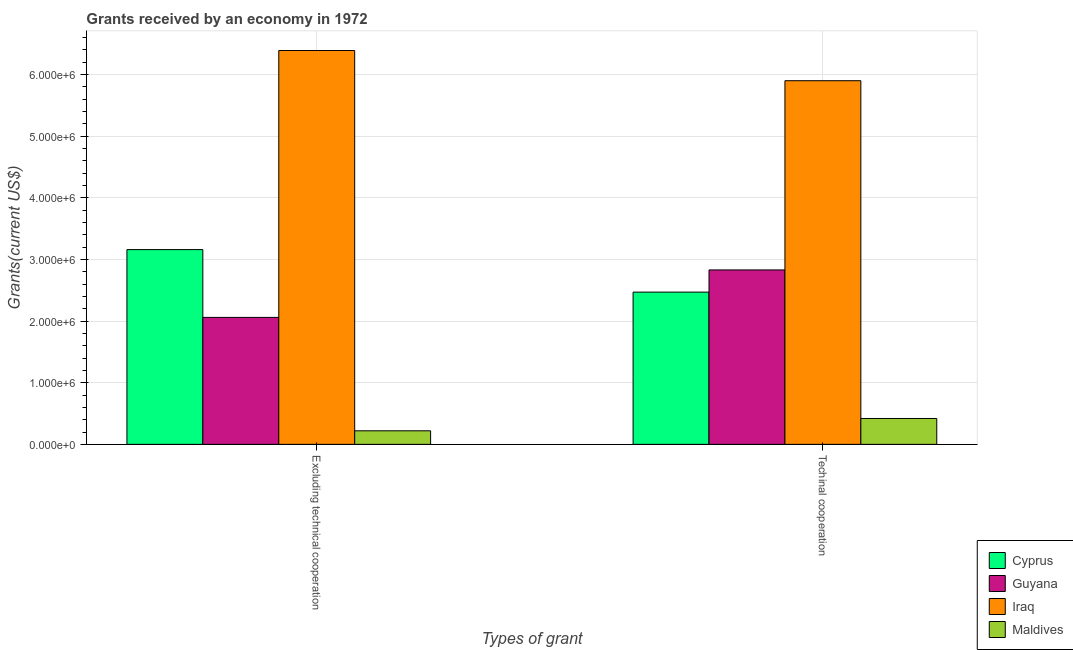How many groups of bars are there?
Your response must be concise. 2. Are the number of bars per tick equal to the number of legend labels?
Make the answer very short. Yes. Are the number of bars on each tick of the X-axis equal?
Offer a very short reply. Yes. How many bars are there on the 2nd tick from the left?
Provide a short and direct response. 4. What is the label of the 1st group of bars from the left?
Your answer should be very brief. Excluding technical cooperation. What is the amount of grants received(excluding technical cooperation) in Maldives?
Keep it short and to the point. 2.20e+05. Across all countries, what is the maximum amount of grants received(including technical cooperation)?
Your answer should be very brief. 5.90e+06. Across all countries, what is the minimum amount of grants received(including technical cooperation)?
Make the answer very short. 4.20e+05. In which country was the amount of grants received(excluding technical cooperation) maximum?
Your answer should be compact. Iraq. In which country was the amount of grants received(excluding technical cooperation) minimum?
Your response must be concise. Maldives. What is the total amount of grants received(excluding technical cooperation) in the graph?
Your answer should be compact. 1.18e+07. What is the difference between the amount of grants received(including technical cooperation) in Iraq and that in Cyprus?
Offer a terse response. 3.43e+06. What is the difference between the amount of grants received(including technical cooperation) in Cyprus and the amount of grants received(excluding technical cooperation) in Iraq?
Offer a terse response. -3.92e+06. What is the average amount of grants received(including technical cooperation) per country?
Your answer should be very brief. 2.90e+06. What is the difference between the amount of grants received(excluding technical cooperation) and amount of grants received(including technical cooperation) in Iraq?
Make the answer very short. 4.90e+05. What is the ratio of the amount of grants received(including technical cooperation) in Iraq to that in Cyprus?
Your answer should be compact. 2.39. What does the 3rd bar from the left in Techinal cooperation represents?
Keep it short and to the point. Iraq. What does the 1st bar from the right in Excluding technical cooperation represents?
Offer a terse response. Maldives. How many bars are there?
Your response must be concise. 8. Are the values on the major ticks of Y-axis written in scientific E-notation?
Offer a terse response. Yes. Does the graph contain grids?
Ensure brevity in your answer.  Yes. How are the legend labels stacked?
Offer a very short reply. Vertical. What is the title of the graph?
Make the answer very short. Grants received by an economy in 1972. What is the label or title of the X-axis?
Offer a very short reply. Types of grant. What is the label or title of the Y-axis?
Your response must be concise. Grants(current US$). What is the Grants(current US$) of Cyprus in Excluding technical cooperation?
Your answer should be very brief. 3.16e+06. What is the Grants(current US$) of Guyana in Excluding technical cooperation?
Offer a very short reply. 2.06e+06. What is the Grants(current US$) of Iraq in Excluding technical cooperation?
Provide a succinct answer. 6.39e+06. What is the Grants(current US$) in Cyprus in Techinal cooperation?
Keep it short and to the point. 2.47e+06. What is the Grants(current US$) of Guyana in Techinal cooperation?
Provide a short and direct response. 2.83e+06. What is the Grants(current US$) in Iraq in Techinal cooperation?
Provide a short and direct response. 5.90e+06. What is the Grants(current US$) of Maldives in Techinal cooperation?
Give a very brief answer. 4.20e+05. Across all Types of grant, what is the maximum Grants(current US$) of Cyprus?
Provide a short and direct response. 3.16e+06. Across all Types of grant, what is the maximum Grants(current US$) of Guyana?
Your response must be concise. 2.83e+06. Across all Types of grant, what is the maximum Grants(current US$) in Iraq?
Your response must be concise. 6.39e+06. Across all Types of grant, what is the minimum Grants(current US$) of Cyprus?
Offer a very short reply. 2.47e+06. Across all Types of grant, what is the minimum Grants(current US$) in Guyana?
Your answer should be very brief. 2.06e+06. Across all Types of grant, what is the minimum Grants(current US$) of Iraq?
Your answer should be very brief. 5.90e+06. Across all Types of grant, what is the minimum Grants(current US$) of Maldives?
Your answer should be compact. 2.20e+05. What is the total Grants(current US$) in Cyprus in the graph?
Your answer should be very brief. 5.63e+06. What is the total Grants(current US$) in Guyana in the graph?
Your answer should be compact. 4.89e+06. What is the total Grants(current US$) of Iraq in the graph?
Keep it short and to the point. 1.23e+07. What is the total Grants(current US$) of Maldives in the graph?
Make the answer very short. 6.40e+05. What is the difference between the Grants(current US$) of Cyprus in Excluding technical cooperation and that in Techinal cooperation?
Ensure brevity in your answer.  6.90e+05. What is the difference between the Grants(current US$) in Guyana in Excluding technical cooperation and that in Techinal cooperation?
Make the answer very short. -7.70e+05. What is the difference between the Grants(current US$) of Maldives in Excluding technical cooperation and that in Techinal cooperation?
Offer a terse response. -2.00e+05. What is the difference between the Grants(current US$) in Cyprus in Excluding technical cooperation and the Grants(current US$) in Iraq in Techinal cooperation?
Your response must be concise. -2.74e+06. What is the difference between the Grants(current US$) in Cyprus in Excluding technical cooperation and the Grants(current US$) in Maldives in Techinal cooperation?
Keep it short and to the point. 2.74e+06. What is the difference between the Grants(current US$) of Guyana in Excluding technical cooperation and the Grants(current US$) of Iraq in Techinal cooperation?
Offer a terse response. -3.84e+06. What is the difference between the Grants(current US$) in Guyana in Excluding technical cooperation and the Grants(current US$) in Maldives in Techinal cooperation?
Your answer should be compact. 1.64e+06. What is the difference between the Grants(current US$) in Iraq in Excluding technical cooperation and the Grants(current US$) in Maldives in Techinal cooperation?
Ensure brevity in your answer.  5.97e+06. What is the average Grants(current US$) in Cyprus per Types of grant?
Your response must be concise. 2.82e+06. What is the average Grants(current US$) of Guyana per Types of grant?
Provide a succinct answer. 2.44e+06. What is the average Grants(current US$) of Iraq per Types of grant?
Provide a succinct answer. 6.14e+06. What is the average Grants(current US$) in Maldives per Types of grant?
Keep it short and to the point. 3.20e+05. What is the difference between the Grants(current US$) in Cyprus and Grants(current US$) in Guyana in Excluding technical cooperation?
Ensure brevity in your answer.  1.10e+06. What is the difference between the Grants(current US$) of Cyprus and Grants(current US$) of Iraq in Excluding technical cooperation?
Make the answer very short. -3.23e+06. What is the difference between the Grants(current US$) in Cyprus and Grants(current US$) in Maldives in Excluding technical cooperation?
Offer a very short reply. 2.94e+06. What is the difference between the Grants(current US$) of Guyana and Grants(current US$) of Iraq in Excluding technical cooperation?
Make the answer very short. -4.33e+06. What is the difference between the Grants(current US$) of Guyana and Grants(current US$) of Maldives in Excluding technical cooperation?
Provide a succinct answer. 1.84e+06. What is the difference between the Grants(current US$) of Iraq and Grants(current US$) of Maldives in Excluding technical cooperation?
Your answer should be very brief. 6.17e+06. What is the difference between the Grants(current US$) in Cyprus and Grants(current US$) in Guyana in Techinal cooperation?
Your answer should be compact. -3.60e+05. What is the difference between the Grants(current US$) of Cyprus and Grants(current US$) of Iraq in Techinal cooperation?
Offer a very short reply. -3.43e+06. What is the difference between the Grants(current US$) in Cyprus and Grants(current US$) in Maldives in Techinal cooperation?
Make the answer very short. 2.05e+06. What is the difference between the Grants(current US$) of Guyana and Grants(current US$) of Iraq in Techinal cooperation?
Your response must be concise. -3.07e+06. What is the difference between the Grants(current US$) in Guyana and Grants(current US$) in Maldives in Techinal cooperation?
Make the answer very short. 2.41e+06. What is the difference between the Grants(current US$) of Iraq and Grants(current US$) of Maldives in Techinal cooperation?
Your answer should be compact. 5.48e+06. What is the ratio of the Grants(current US$) in Cyprus in Excluding technical cooperation to that in Techinal cooperation?
Keep it short and to the point. 1.28. What is the ratio of the Grants(current US$) in Guyana in Excluding technical cooperation to that in Techinal cooperation?
Offer a very short reply. 0.73. What is the ratio of the Grants(current US$) in Iraq in Excluding technical cooperation to that in Techinal cooperation?
Your answer should be compact. 1.08. What is the ratio of the Grants(current US$) of Maldives in Excluding technical cooperation to that in Techinal cooperation?
Your answer should be very brief. 0.52. What is the difference between the highest and the second highest Grants(current US$) of Cyprus?
Provide a short and direct response. 6.90e+05. What is the difference between the highest and the second highest Grants(current US$) in Guyana?
Your answer should be compact. 7.70e+05. What is the difference between the highest and the second highest Grants(current US$) of Iraq?
Provide a short and direct response. 4.90e+05. What is the difference between the highest and the lowest Grants(current US$) in Cyprus?
Offer a terse response. 6.90e+05. What is the difference between the highest and the lowest Grants(current US$) of Guyana?
Provide a succinct answer. 7.70e+05. What is the difference between the highest and the lowest Grants(current US$) in Maldives?
Provide a succinct answer. 2.00e+05. 